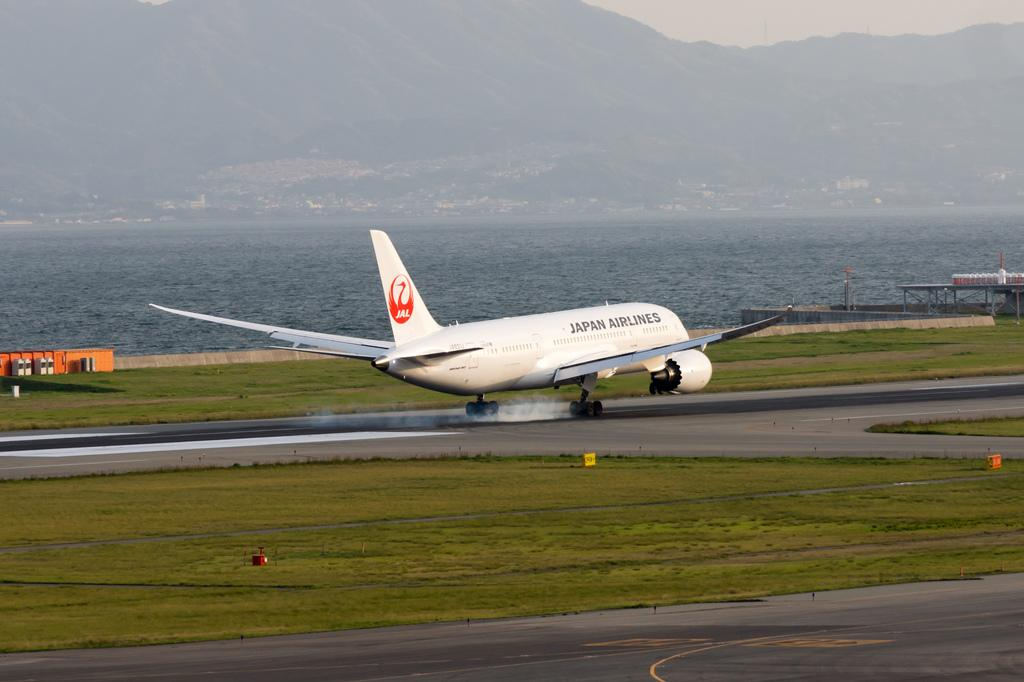<image>
Share a concise interpretation of the image provided. A Japan Airlines airplane is landing on a landing strip. 